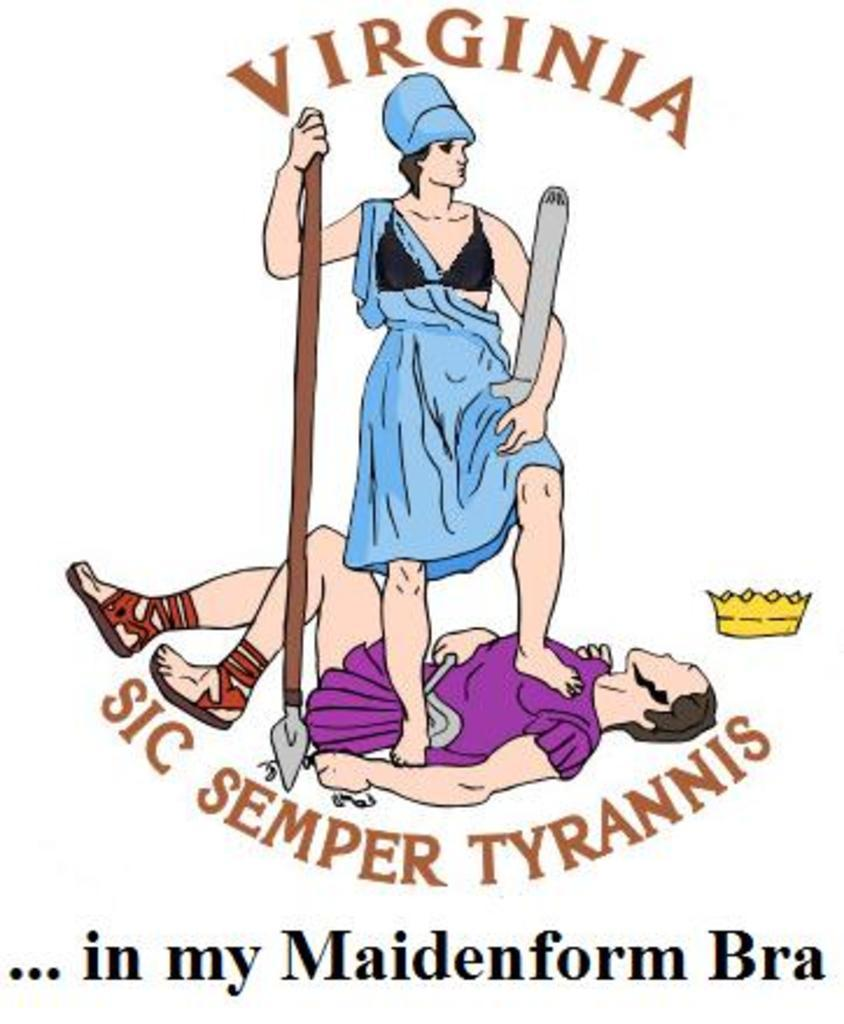What is depicted in the cartoon image in the picture? There is a cartoon image of a woman and a person in the picture. What is the woman doing to the person in the image? The woman is standing on the man in the image. What is the woman holding in her hand in the image? The woman is holding something in her hand in the image. What additional information is provided on the image? There is text written on the image. What type of crack is visible in the image? There is no crack visible in the image; it features a cartoon image of a woman and a person. What color is the vest worn by the person in the image? There is no vest visible in the image; the person is not wearing any clothing. 